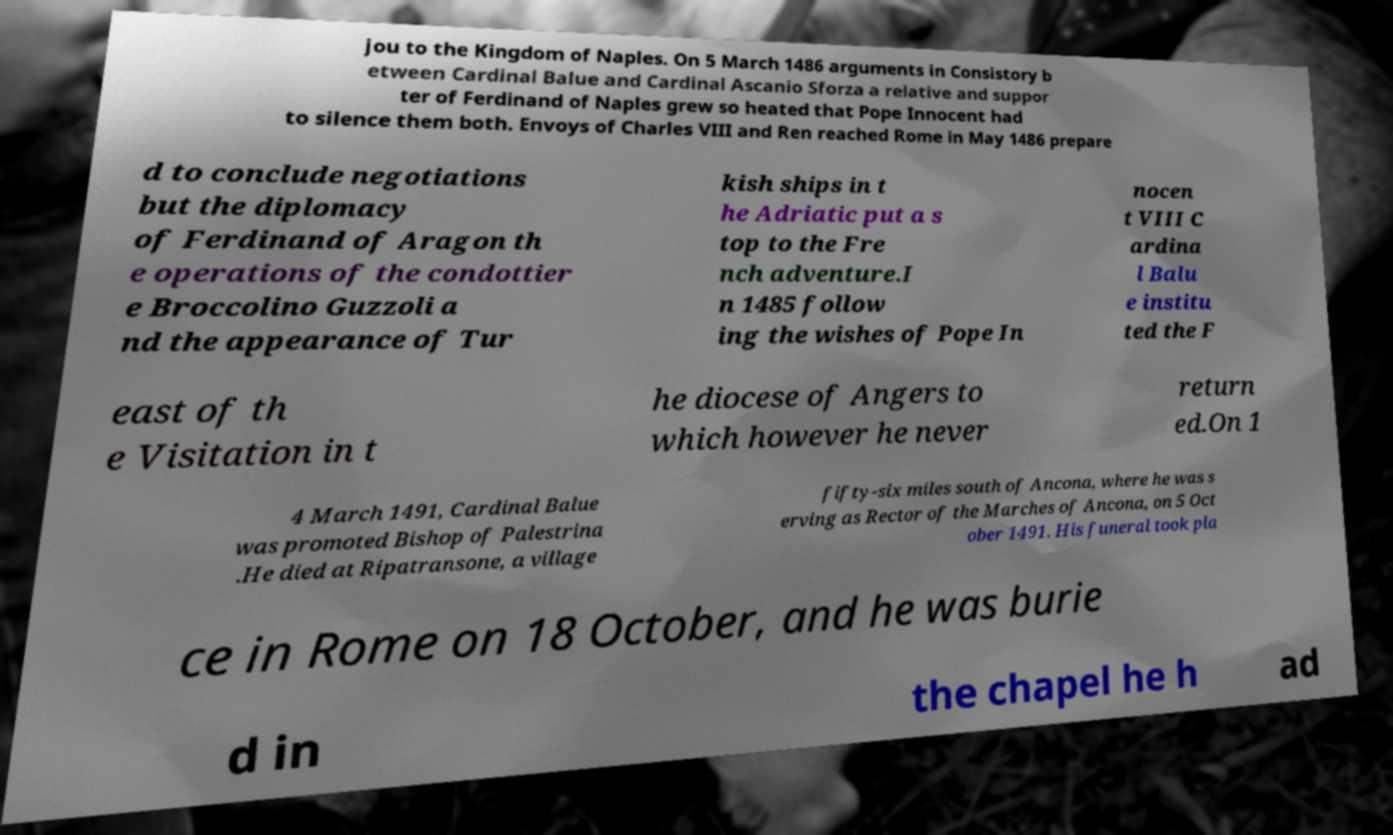Could you extract and type out the text from this image? jou to the Kingdom of Naples. On 5 March 1486 arguments in Consistory b etween Cardinal Balue and Cardinal Ascanio Sforza a relative and suppor ter of Ferdinand of Naples grew so heated that Pope Innocent had to silence them both. Envoys of Charles VIII and Ren reached Rome in May 1486 prepare d to conclude negotiations but the diplomacy of Ferdinand of Aragon th e operations of the condottier e Broccolino Guzzoli a nd the appearance of Tur kish ships in t he Adriatic put a s top to the Fre nch adventure.I n 1485 follow ing the wishes of Pope In nocen t VIII C ardina l Balu e institu ted the F east of th e Visitation in t he diocese of Angers to which however he never return ed.On 1 4 March 1491, Cardinal Balue was promoted Bishop of Palestrina .He died at Ripatransone, a village fifty-six miles south of Ancona, where he was s erving as Rector of the Marches of Ancona, on 5 Oct ober 1491. His funeral took pla ce in Rome on 18 October, and he was burie d in the chapel he h ad 